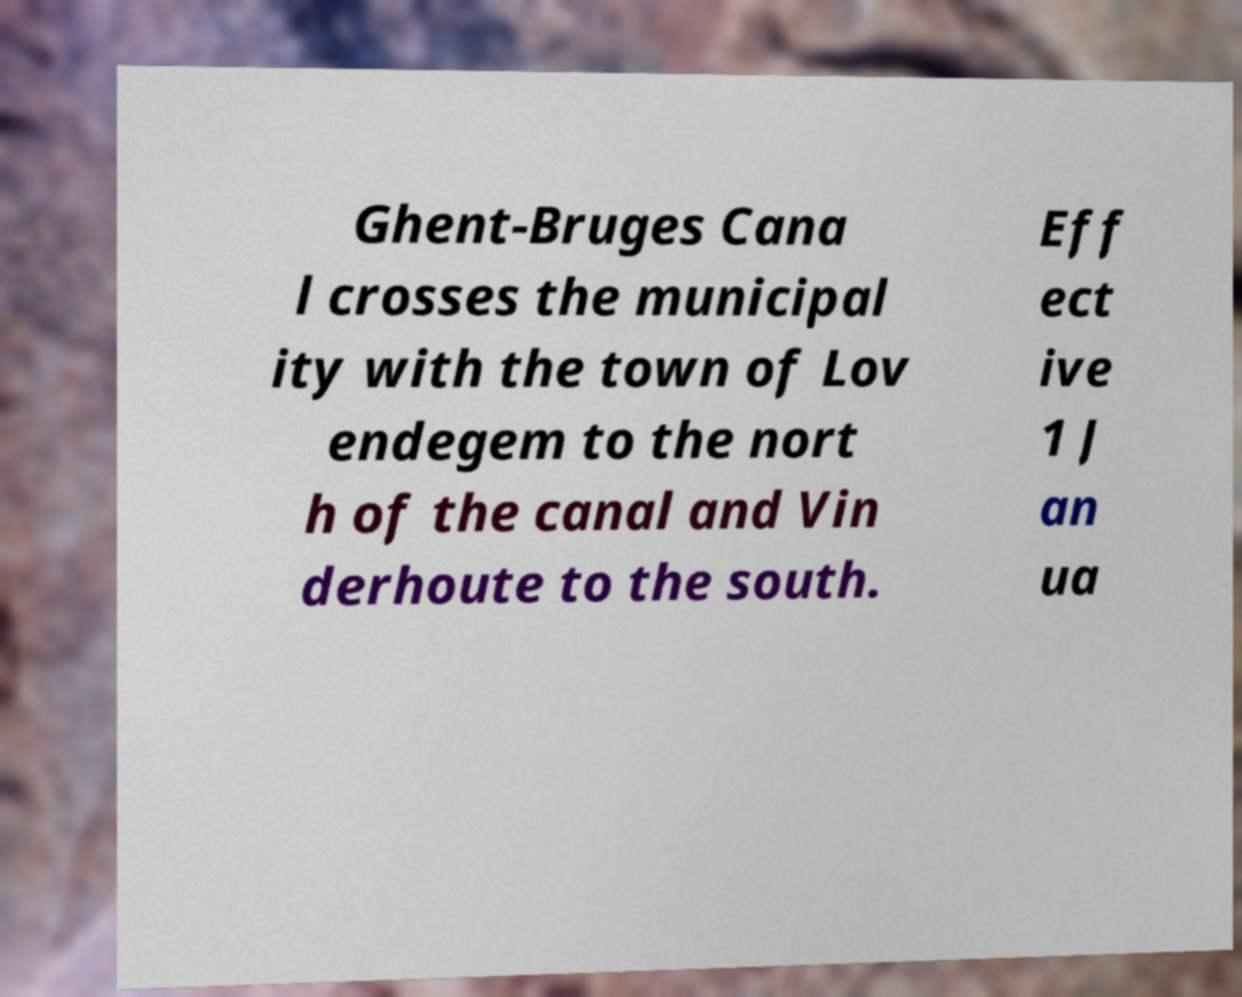I need the written content from this picture converted into text. Can you do that? Ghent-Bruges Cana l crosses the municipal ity with the town of Lov endegem to the nort h of the canal and Vin derhoute to the south. Eff ect ive 1 J an ua 